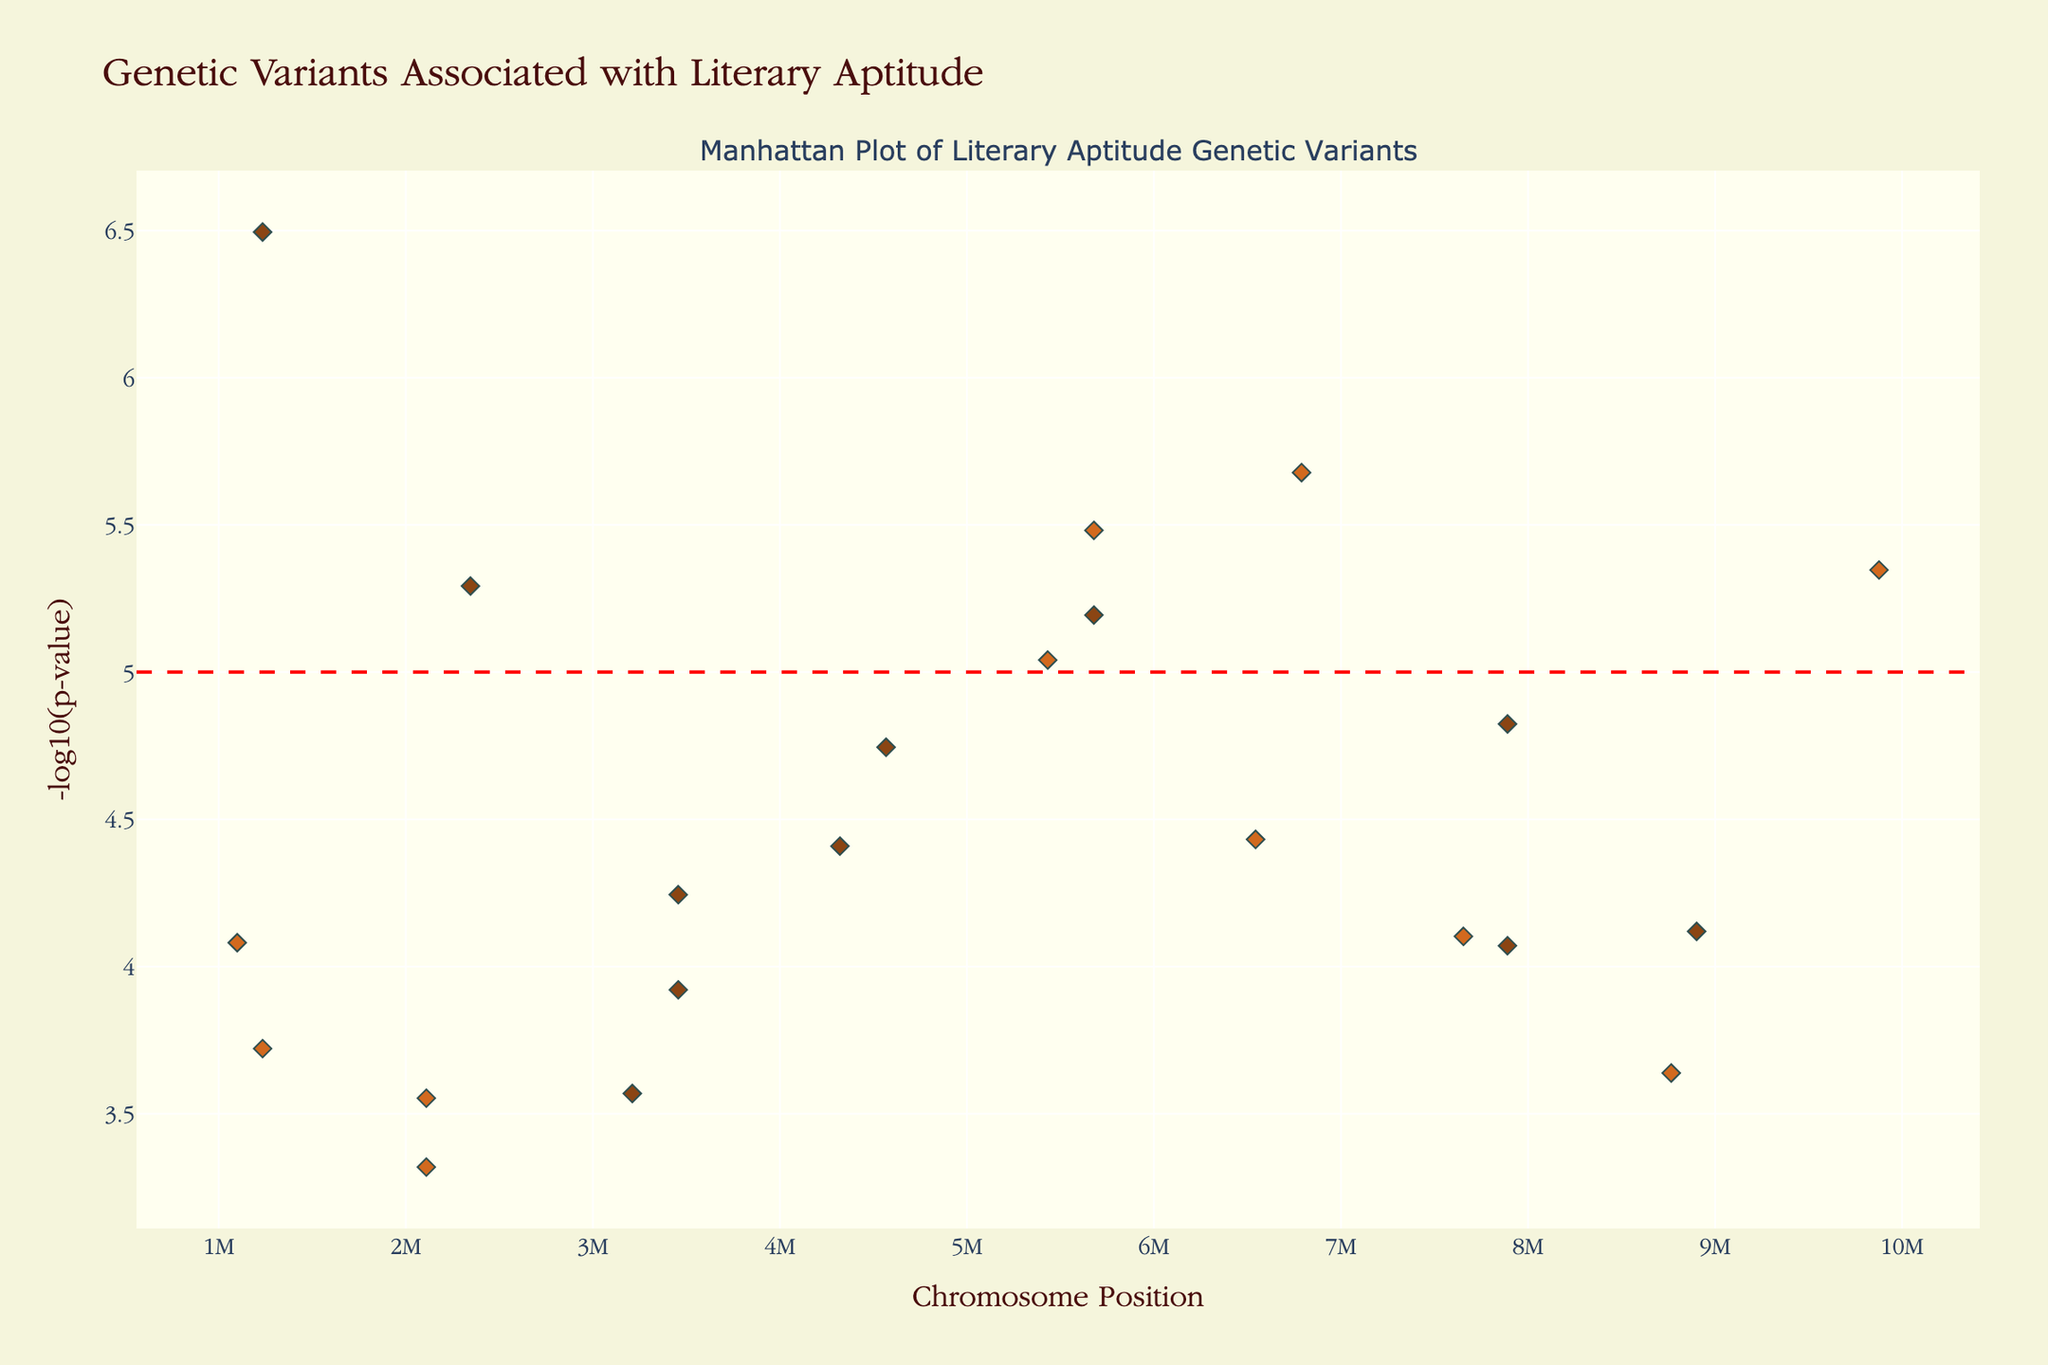What is the title of the plot? The title is usually displayed at the top of the figure in a larger font size. In this case, the title is "Genetic Variants Associated with Literary Aptitude".
Answer: Genetic Variants Associated with Literary Aptitude What does the y-axis represent? The y-axis label describes the measure plotted on this axis. Here, it is labeled as "-log10(p-value)", which indicates the negative logarithm of the p-value for each genetic variant.
Answer: -log10(p-value) Which chromosome has the highest number of data points? Identify the chromosome with the most markers displayed. From the figure, chromosome 1 appears to have the highest number of data points as it spans the largest range of x-axis positions.
Answer: Chromosome 1 What is the threshold for significance indicated by the horizontal line? The horizontal line's position on the y-axis indicates the significance threshold. Here, the line is at y=5, representing the -log10(p-value) cutoff for significance.
Answer: 5 Which SNP on chromosome 20 has the lowest p-value, and what is the associated gene? The position of the dots can tell us the lowest p-value on chromosome 20 by identifying the highest point on the y-axis for this chromosome. The highest dot on chromosome 20 corresponds to SNPrs6277 associated with the gene DRD2.
Answer: rs6277, DRD2 Which chromosome has the SNP associated with the FOXP2 gene, and what is the approximate p-value of this SNP? Locate the FOXP2 label among the annotations and check its x and y positions. The FOXP2 gene is associated with SNP rs2229544 on chromosome 1, with a p-value approximately 3.2e-7. The corresponding -log10(p-value) is approximately 6.49.
Answer: Chromosome 1, 3.2e-7 (approx) How many genes have SNPs with p-values lower than 1e-5? Count the number of SNPs that exceed the -log10(1e-5) line on the y-axis. The line for -log10(1e-5) is at y=5, so we count the data points above this threshold. There are 5 SNPs above this threshold: rs2229544 (FOXP2), rs6733871(CNTNAP2), rs9461045(KIAA0319), rs1042778(OXTR), and rs6277(DRD2).
Answer: 5 Which SNP is closest to the significance threshold but does not cross it, and what is the associated gene? Identify the highest data point below the red dashed line (which represents the significance threshold at -log10(p-value) = 5). The closest SNP to the threshold is rs2074130 associated with the ASPM gene, with a -log10(p-value) below 5.
Answer: rs2074130, ASPM 